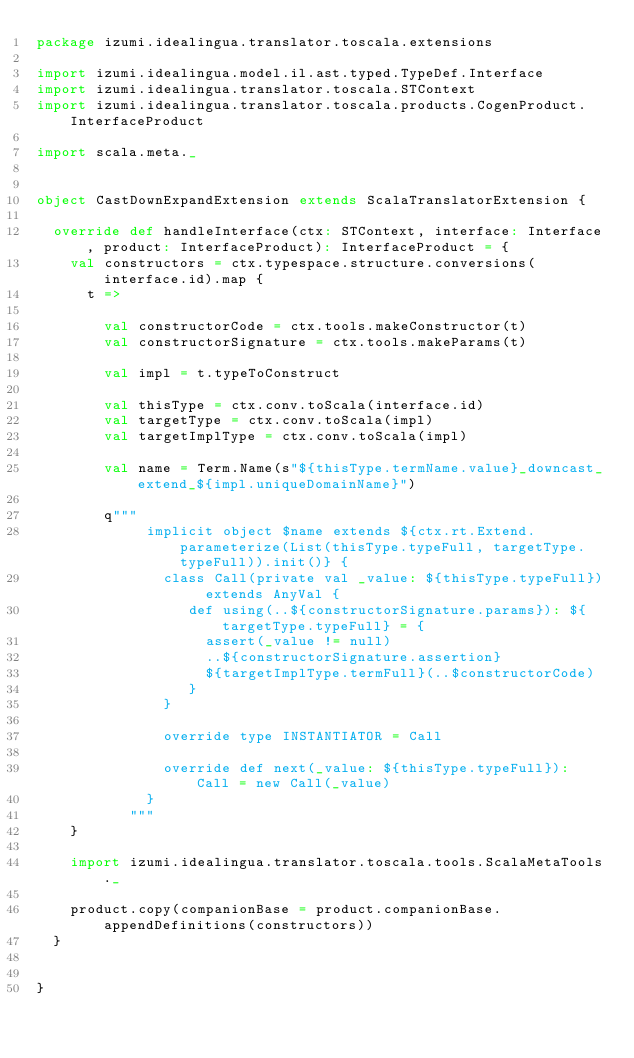Convert code to text. <code><loc_0><loc_0><loc_500><loc_500><_Scala_>package izumi.idealingua.translator.toscala.extensions

import izumi.idealingua.model.il.ast.typed.TypeDef.Interface
import izumi.idealingua.translator.toscala.STContext
import izumi.idealingua.translator.toscala.products.CogenProduct.InterfaceProduct

import scala.meta._


object CastDownExpandExtension extends ScalaTranslatorExtension {

  override def handleInterface(ctx: STContext, interface: Interface, product: InterfaceProduct): InterfaceProduct = {
    val constructors = ctx.typespace.structure.conversions(interface.id).map {
      t =>

        val constructorCode = ctx.tools.makeConstructor(t)
        val constructorSignature = ctx.tools.makeParams(t)

        val impl = t.typeToConstruct

        val thisType = ctx.conv.toScala(interface.id)
        val targetType = ctx.conv.toScala(impl)
        val targetImplType = ctx.conv.toScala(impl)

        val name = Term.Name(s"${thisType.termName.value}_downcast_extend_${impl.uniqueDomainName}")

        q"""
             implicit object $name extends ${ctx.rt.Extend.parameterize(List(thisType.typeFull, targetType.typeFull)).init()} {
               class Call(private val _value: ${thisType.typeFull}) extends AnyVal {
                  def using(..${constructorSignature.params}): ${targetType.typeFull} = {
                    assert(_value != null)
                    ..${constructorSignature.assertion}
                    ${targetImplType.termFull}(..$constructorCode)
                  }
               }

               override type INSTANTIATOR = Call

               override def next(_value: ${thisType.typeFull}): Call = new Call(_value)
             }
           """
    }

    import izumi.idealingua.translator.toscala.tools.ScalaMetaTools._

    product.copy(companionBase = product.companionBase.appendDefinitions(constructors))
  }


}
</code> 